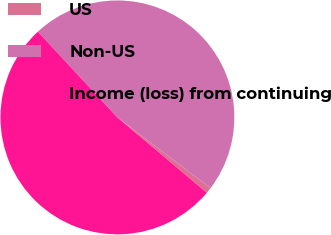Convert chart to OTSL. <chart><loc_0><loc_0><loc_500><loc_500><pie_chart><fcel>US<fcel>Non-US<fcel>Income (loss) from continuing<nl><fcel>0.8%<fcel>47.24%<fcel>51.96%<nl></chart> 